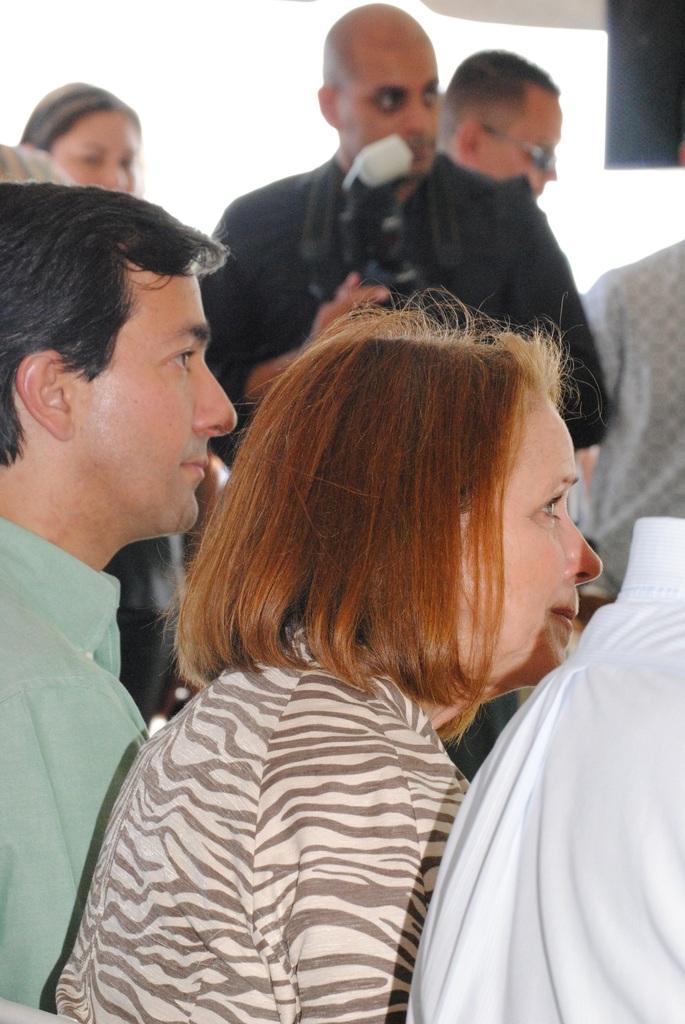How would you summarize this image in a sentence or two? In this picture I can see a man and a woman in front and I see few people in the background and I see that the man in the middle of the picture is holding a camera. 